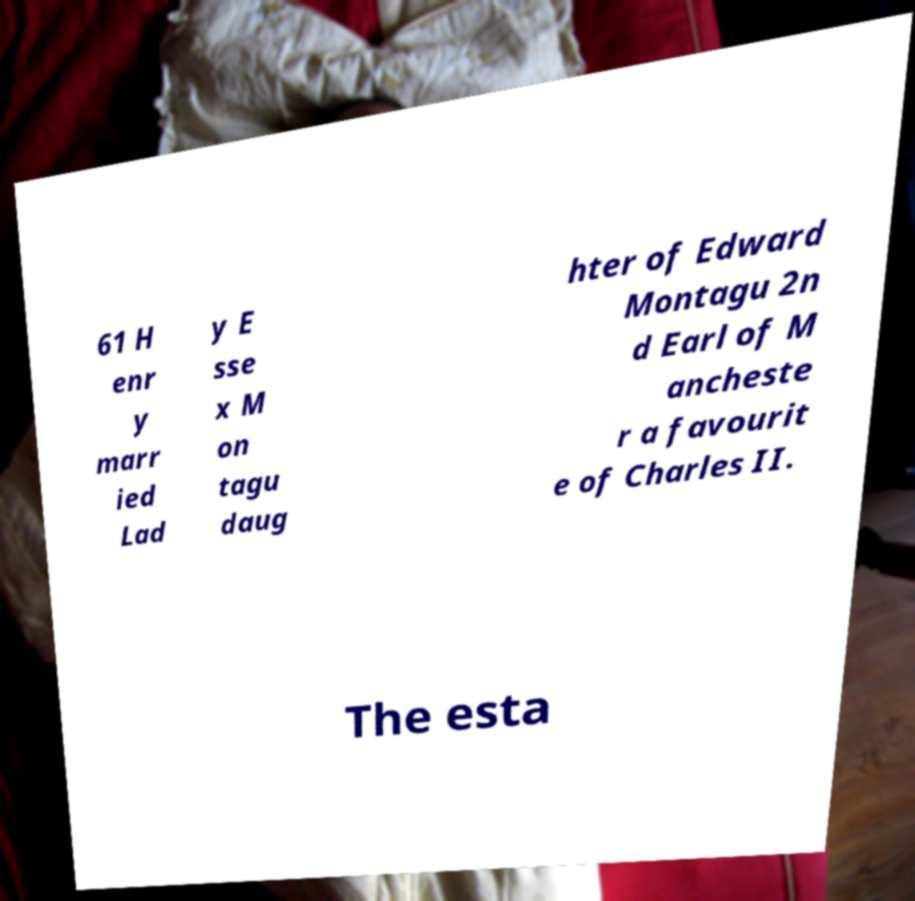Could you assist in decoding the text presented in this image and type it out clearly? 61 H enr y marr ied Lad y E sse x M on tagu daug hter of Edward Montagu 2n d Earl of M ancheste r a favourit e of Charles II. The esta 